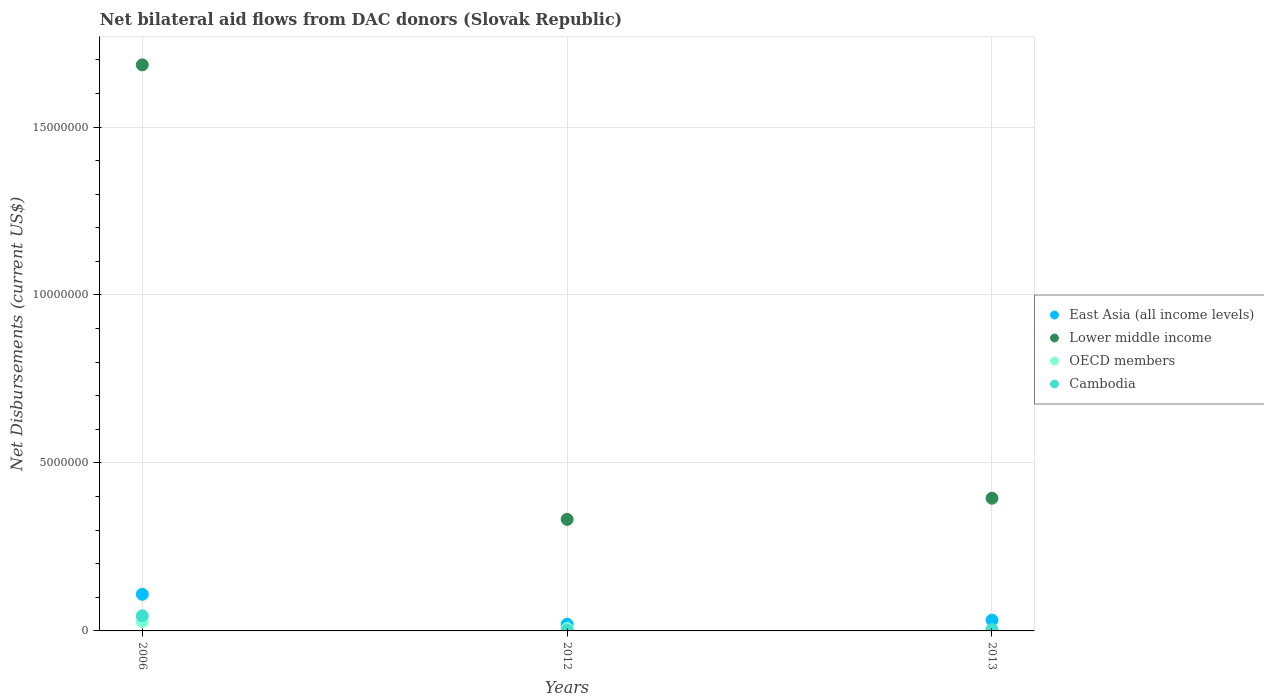What is the net bilateral aid flows in OECD members in 2013?
Ensure brevity in your answer.  10000. Across all years, what is the maximum net bilateral aid flows in East Asia (all income levels)?
Your response must be concise. 1.09e+06. Across all years, what is the minimum net bilateral aid flows in Cambodia?
Your answer should be compact. 2.00e+04. What is the total net bilateral aid flows in Lower middle income in the graph?
Offer a terse response. 2.41e+07. What is the difference between the net bilateral aid flows in OECD members in 2006 and the net bilateral aid flows in Lower middle income in 2013?
Make the answer very short. -3.67e+06. What is the average net bilateral aid flows in East Asia (all income levels) per year?
Ensure brevity in your answer.  5.37e+05. In the year 2006, what is the difference between the net bilateral aid flows in Cambodia and net bilateral aid flows in OECD members?
Offer a terse response. 1.70e+05. What is the ratio of the net bilateral aid flows in OECD members in 2012 to that in 2013?
Ensure brevity in your answer.  7. Is the net bilateral aid flows in Cambodia in 2012 less than that in 2013?
Provide a succinct answer. Yes. Is the difference between the net bilateral aid flows in Cambodia in 2006 and 2013 greater than the difference between the net bilateral aid flows in OECD members in 2006 and 2013?
Provide a succinct answer. Yes. What is the difference between the highest and the second highest net bilateral aid flows in OECD members?
Your response must be concise. 2.10e+05. What is the difference between the highest and the lowest net bilateral aid flows in East Asia (all income levels)?
Ensure brevity in your answer.  8.90e+05. Does the net bilateral aid flows in Lower middle income monotonically increase over the years?
Give a very brief answer. No. Is the net bilateral aid flows in Lower middle income strictly greater than the net bilateral aid flows in East Asia (all income levels) over the years?
Your answer should be very brief. Yes. How many dotlines are there?
Keep it short and to the point. 4. Are the values on the major ticks of Y-axis written in scientific E-notation?
Ensure brevity in your answer.  No. How many legend labels are there?
Offer a very short reply. 4. What is the title of the graph?
Give a very brief answer. Net bilateral aid flows from DAC donors (Slovak Republic). Does "Denmark" appear as one of the legend labels in the graph?
Your response must be concise. No. What is the label or title of the Y-axis?
Provide a short and direct response. Net Disbursements (current US$). What is the Net Disbursements (current US$) in East Asia (all income levels) in 2006?
Your response must be concise. 1.09e+06. What is the Net Disbursements (current US$) of Lower middle income in 2006?
Make the answer very short. 1.68e+07. What is the Net Disbursements (current US$) in Cambodia in 2006?
Offer a very short reply. 4.50e+05. What is the Net Disbursements (current US$) in East Asia (all income levels) in 2012?
Offer a very short reply. 2.00e+05. What is the Net Disbursements (current US$) in Lower middle income in 2012?
Provide a succinct answer. 3.32e+06. What is the Net Disbursements (current US$) of East Asia (all income levels) in 2013?
Give a very brief answer. 3.20e+05. What is the Net Disbursements (current US$) in Lower middle income in 2013?
Make the answer very short. 3.95e+06. Across all years, what is the maximum Net Disbursements (current US$) of East Asia (all income levels)?
Offer a very short reply. 1.09e+06. Across all years, what is the maximum Net Disbursements (current US$) of Lower middle income?
Your answer should be compact. 1.68e+07. Across all years, what is the minimum Net Disbursements (current US$) in Lower middle income?
Ensure brevity in your answer.  3.32e+06. Across all years, what is the minimum Net Disbursements (current US$) of OECD members?
Offer a terse response. 10000. Across all years, what is the minimum Net Disbursements (current US$) in Cambodia?
Your answer should be very brief. 2.00e+04. What is the total Net Disbursements (current US$) of East Asia (all income levels) in the graph?
Keep it short and to the point. 1.61e+06. What is the total Net Disbursements (current US$) in Lower middle income in the graph?
Offer a very short reply. 2.41e+07. What is the total Net Disbursements (current US$) of OECD members in the graph?
Provide a short and direct response. 3.60e+05. What is the total Net Disbursements (current US$) of Cambodia in the graph?
Offer a terse response. 5.10e+05. What is the difference between the Net Disbursements (current US$) in East Asia (all income levels) in 2006 and that in 2012?
Your answer should be compact. 8.90e+05. What is the difference between the Net Disbursements (current US$) in Lower middle income in 2006 and that in 2012?
Keep it short and to the point. 1.35e+07. What is the difference between the Net Disbursements (current US$) of Cambodia in 2006 and that in 2012?
Your answer should be very brief. 4.30e+05. What is the difference between the Net Disbursements (current US$) of East Asia (all income levels) in 2006 and that in 2013?
Provide a short and direct response. 7.70e+05. What is the difference between the Net Disbursements (current US$) in Lower middle income in 2006 and that in 2013?
Offer a terse response. 1.29e+07. What is the difference between the Net Disbursements (current US$) of East Asia (all income levels) in 2012 and that in 2013?
Make the answer very short. -1.20e+05. What is the difference between the Net Disbursements (current US$) in Lower middle income in 2012 and that in 2013?
Make the answer very short. -6.30e+05. What is the difference between the Net Disbursements (current US$) of Cambodia in 2012 and that in 2013?
Make the answer very short. -2.00e+04. What is the difference between the Net Disbursements (current US$) in East Asia (all income levels) in 2006 and the Net Disbursements (current US$) in Lower middle income in 2012?
Your answer should be compact. -2.23e+06. What is the difference between the Net Disbursements (current US$) in East Asia (all income levels) in 2006 and the Net Disbursements (current US$) in OECD members in 2012?
Offer a very short reply. 1.02e+06. What is the difference between the Net Disbursements (current US$) of East Asia (all income levels) in 2006 and the Net Disbursements (current US$) of Cambodia in 2012?
Provide a succinct answer. 1.07e+06. What is the difference between the Net Disbursements (current US$) in Lower middle income in 2006 and the Net Disbursements (current US$) in OECD members in 2012?
Your answer should be very brief. 1.68e+07. What is the difference between the Net Disbursements (current US$) in Lower middle income in 2006 and the Net Disbursements (current US$) in Cambodia in 2012?
Offer a terse response. 1.68e+07. What is the difference between the Net Disbursements (current US$) of OECD members in 2006 and the Net Disbursements (current US$) of Cambodia in 2012?
Make the answer very short. 2.60e+05. What is the difference between the Net Disbursements (current US$) in East Asia (all income levels) in 2006 and the Net Disbursements (current US$) in Lower middle income in 2013?
Ensure brevity in your answer.  -2.86e+06. What is the difference between the Net Disbursements (current US$) in East Asia (all income levels) in 2006 and the Net Disbursements (current US$) in OECD members in 2013?
Ensure brevity in your answer.  1.08e+06. What is the difference between the Net Disbursements (current US$) of East Asia (all income levels) in 2006 and the Net Disbursements (current US$) of Cambodia in 2013?
Your answer should be compact. 1.05e+06. What is the difference between the Net Disbursements (current US$) in Lower middle income in 2006 and the Net Disbursements (current US$) in OECD members in 2013?
Your response must be concise. 1.68e+07. What is the difference between the Net Disbursements (current US$) of Lower middle income in 2006 and the Net Disbursements (current US$) of Cambodia in 2013?
Offer a very short reply. 1.68e+07. What is the difference between the Net Disbursements (current US$) of OECD members in 2006 and the Net Disbursements (current US$) of Cambodia in 2013?
Keep it short and to the point. 2.40e+05. What is the difference between the Net Disbursements (current US$) of East Asia (all income levels) in 2012 and the Net Disbursements (current US$) of Lower middle income in 2013?
Make the answer very short. -3.75e+06. What is the difference between the Net Disbursements (current US$) in East Asia (all income levels) in 2012 and the Net Disbursements (current US$) in OECD members in 2013?
Offer a terse response. 1.90e+05. What is the difference between the Net Disbursements (current US$) of East Asia (all income levels) in 2012 and the Net Disbursements (current US$) of Cambodia in 2013?
Give a very brief answer. 1.60e+05. What is the difference between the Net Disbursements (current US$) in Lower middle income in 2012 and the Net Disbursements (current US$) in OECD members in 2013?
Your answer should be very brief. 3.31e+06. What is the difference between the Net Disbursements (current US$) in Lower middle income in 2012 and the Net Disbursements (current US$) in Cambodia in 2013?
Provide a succinct answer. 3.28e+06. What is the average Net Disbursements (current US$) of East Asia (all income levels) per year?
Offer a very short reply. 5.37e+05. What is the average Net Disbursements (current US$) in Lower middle income per year?
Your answer should be very brief. 8.04e+06. What is the average Net Disbursements (current US$) of OECD members per year?
Make the answer very short. 1.20e+05. In the year 2006, what is the difference between the Net Disbursements (current US$) in East Asia (all income levels) and Net Disbursements (current US$) in Lower middle income?
Provide a succinct answer. -1.58e+07. In the year 2006, what is the difference between the Net Disbursements (current US$) in East Asia (all income levels) and Net Disbursements (current US$) in OECD members?
Provide a short and direct response. 8.10e+05. In the year 2006, what is the difference between the Net Disbursements (current US$) of East Asia (all income levels) and Net Disbursements (current US$) of Cambodia?
Give a very brief answer. 6.40e+05. In the year 2006, what is the difference between the Net Disbursements (current US$) of Lower middle income and Net Disbursements (current US$) of OECD members?
Offer a terse response. 1.66e+07. In the year 2006, what is the difference between the Net Disbursements (current US$) of Lower middle income and Net Disbursements (current US$) of Cambodia?
Keep it short and to the point. 1.64e+07. In the year 2012, what is the difference between the Net Disbursements (current US$) in East Asia (all income levels) and Net Disbursements (current US$) in Lower middle income?
Give a very brief answer. -3.12e+06. In the year 2012, what is the difference between the Net Disbursements (current US$) of Lower middle income and Net Disbursements (current US$) of OECD members?
Your response must be concise. 3.25e+06. In the year 2012, what is the difference between the Net Disbursements (current US$) in Lower middle income and Net Disbursements (current US$) in Cambodia?
Your response must be concise. 3.30e+06. In the year 2013, what is the difference between the Net Disbursements (current US$) in East Asia (all income levels) and Net Disbursements (current US$) in Lower middle income?
Provide a short and direct response. -3.63e+06. In the year 2013, what is the difference between the Net Disbursements (current US$) of East Asia (all income levels) and Net Disbursements (current US$) of Cambodia?
Provide a succinct answer. 2.80e+05. In the year 2013, what is the difference between the Net Disbursements (current US$) of Lower middle income and Net Disbursements (current US$) of OECD members?
Your response must be concise. 3.94e+06. In the year 2013, what is the difference between the Net Disbursements (current US$) in Lower middle income and Net Disbursements (current US$) in Cambodia?
Offer a terse response. 3.91e+06. What is the ratio of the Net Disbursements (current US$) of East Asia (all income levels) in 2006 to that in 2012?
Give a very brief answer. 5.45. What is the ratio of the Net Disbursements (current US$) of Lower middle income in 2006 to that in 2012?
Keep it short and to the point. 5.08. What is the ratio of the Net Disbursements (current US$) of Cambodia in 2006 to that in 2012?
Provide a short and direct response. 22.5. What is the ratio of the Net Disbursements (current US$) in East Asia (all income levels) in 2006 to that in 2013?
Offer a terse response. 3.41. What is the ratio of the Net Disbursements (current US$) of Lower middle income in 2006 to that in 2013?
Offer a terse response. 4.27. What is the ratio of the Net Disbursements (current US$) of Cambodia in 2006 to that in 2013?
Provide a succinct answer. 11.25. What is the ratio of the Net Disbursements (current US$) of Lower middle income in 2012 to that in 2013?
Your answer should be very brief. 0.84. What is the ratio of the Net Disbursements (current US$) in Cambodia in 2012 to that in 2013?
Your answer should be very brief. 0.5. What is the difference between the highest and the second highest Net Disbursements (current US$) in East Asia (all income levels)?
Give a very brief answer. 7.70e+05. What is the difference between the highest and the second highest Net Disbursements (current US$) of Lower middle income?
Make the answer very short. 1.29e+07. What is the difference between the highest and the lowest Net Disbursements (current US$) of East Asia (all income levels)?
Your response must be concise. 8.90e+05. What is the difference between the highest and the lowest Net Disbursements (current US$) of Lower middle income?
Make the answer very short. 1.35e+07. 